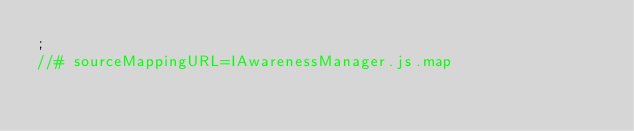<code> <loc_0><loc_0><loc_500><loc_500><_JavaScript_>;
//# sourceMappingURL=IAwarenessManager.js.map</code> 